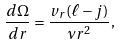Convert formula to latex. <formula><loc_0><loc_0><loc_500><loc_500>\frac { d \Omega } { d r } = \frac { v _ { r } ( \ell - j ) } { \nu r ^ { 2 } } ,</formula> 